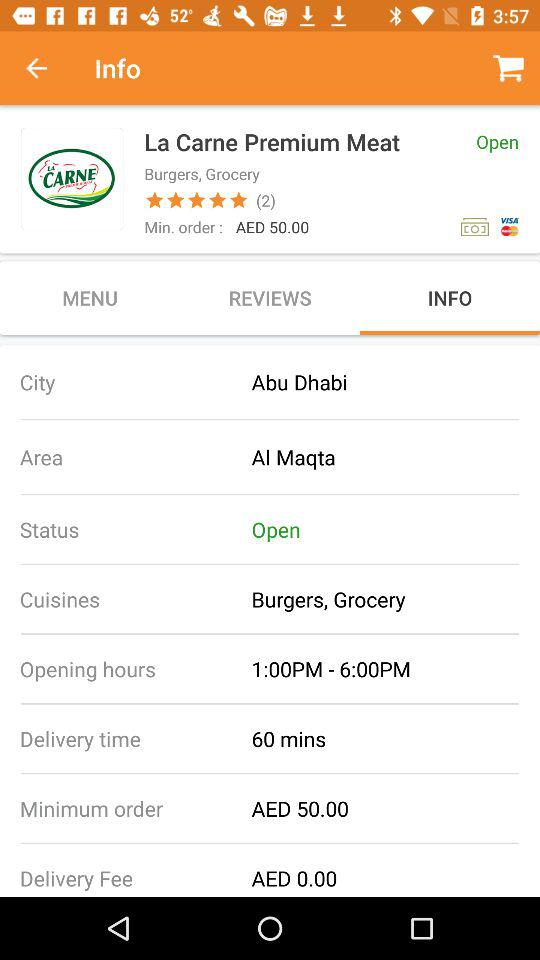Which tab is selected? The selected tab is "INFO". 